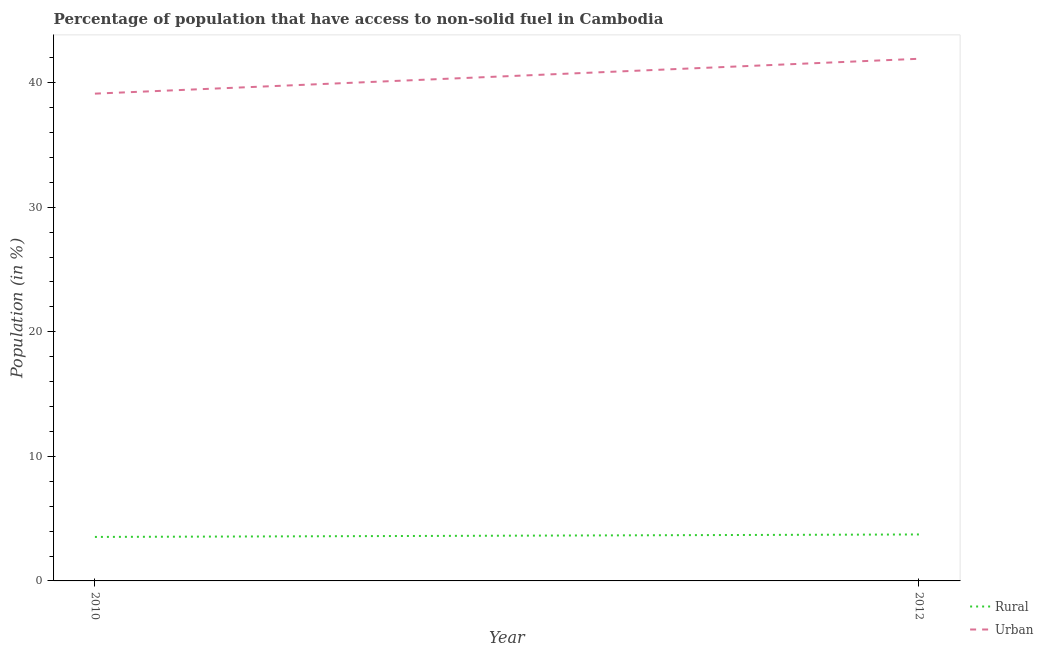How many different coloured lines are there?
Your answer should be compact. 2. Does the line corresponding to rural population intersect with the line corresponding to urban population?
Give a very brief answer. No. Is the number of lines equal to the number of legend labels?
Your answer should be compact. Yes. What is the urban population in 2010?
Give a very brief answer. 39.11. Across all years, what is the maximum rural population?
Keep it short and to the point. 3.73. Across all years, what is the minimum urban population?
Your answer should be compact. 39.11. In which year was the urban population maximum?
Provide a short and direct response. 2012. In which year was the rural population minimum?
Your answer should be very brief. 2010. What is the total urban population in the graph?
Your response must be concise. 81.03. What is the difference between the rural population in 2010 and that in 2012?
Provide a short and direct response. -0.2. What is the difference between the rural population in 2012 and the urban population in 2010?
Keep it short and to the point. -35.38. What is the average rural population per year?
Make the answer very short. 3.63. In the year 2012, what is the difference between the rural population and urban population?
Give a very brief answer. -38.18. What is the ratio of the urban population in 2010 to that in 2012?
Ensure brevity in your answer.  0.93. How many years are there in the graph?
Keep it short and to the point. 2. Does the graph contain any zero values?
Provide a succinct answer. No. How many legend labels are there?
Keep it short and to the point. 2. How are the legend labels stacked?
Provide a short and direct response. Vertical. What is the title of the graph?
Offer a terse response. Percentage of population that have access to non-solid fuel in Cambodia. What is the label or title of the X-axis?
Your response must be concise. Year. What is the label or title of the Y-axis?
Your answer should be very brief. Population (in %). What is the Population (in %) in Rural in 2010?
Make the answer very short. 3.53. What is the Population (in %) in Urban in 2010?
Your answer should be very brief. 39.11. What is the Population (in %) of Rural in 2012?
Provide a short and direct response. 3.73. What is the Population (in %) of Urban in 2012?
Keep it short and to the point. 41.91. Across all years, what is the maximum Population (in %) of Rural?
Offer a very short reply. 3.73. Across all years, what is the maximum Population (in %) in Urban?
Offer a very short reply. 41.91. Across all years, what is the minimum Population (in %) of Rural?
Your response must be concise. 3.53. Across all years, what is the minimum Population (in %) in Urban?
Your answer should be very brief. 39.11. What is the total Population (in %) of Rural in the graph?
Your answer should be compact. 7.26. What is the total Population (in %) of Urban in the graph?
Keep it short and to the point. 81.03. What is the difference between the Population (in %) of Rural in 2010 and that in 2012?
Your response must be concise. -0.2. What is the difference between the Population (in %) in Urban in 2010 and that in 2012?
Ensure brevity in your answer.  -2.8. What is the difference between the Population (in %) of Rural in 2010 and the Population (in %) of Urban in 2012?
Give a very brief answer. -38.38. What is the average Population (in %) in Rural per year?
Provide a short and direct response. 3.63. What is the average Population (in %) of Urban per year?
Provide a succinct answer. 40.51. In the year 2010, what is the difference between the Population (in %) of Rural and Population (in %) of Urban?
Your response must be concise. -35.58. In the year 2012, what is the difference between the Population (in %) of Rural and Population (in %) of Urban?
Offer a very short reply. -38.18. What is the ratio of the Population (in %) in Rural in 2010 to that in 2012?
Offer a terse response. 0.95. What is the ratio of the Population (in %) of Urban in 2010 to that in 2012?
Give a very brief answer. 0.93. What is the difference between the highest and the second highest Population (in %) of Rural?
Provide a succinct answer. 0.2. What is the difference between the highest and the second highest Population (in %) of Urban?
Make the answer very short. 2.8. What is the difference between the highest and the lowest Population (in %) in Rural?
Your answer should be very brief. 0.2. What is the difference between the highest and the lowest Population (in %) in Urban?
Provide a succinct answer. 2.8. 